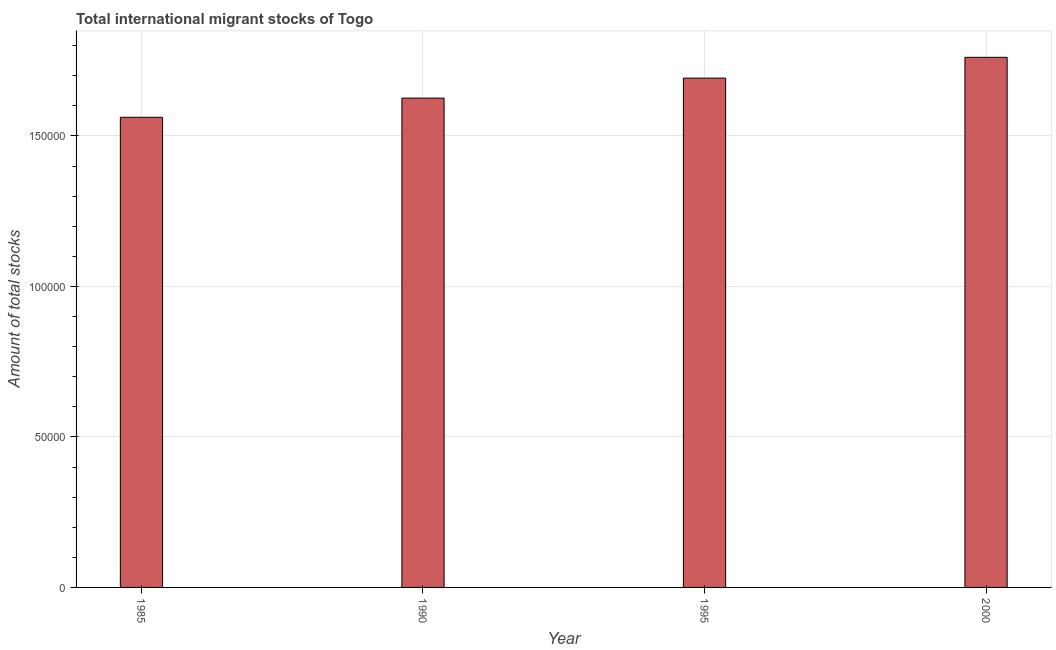What is the title of the graph?
Ensure brevity in your answer.  Total international migrant stocks of Togo. What is the label or title of the X-axis?
Offer a terse response. Year. What is the label or title of the Y-axis?
Your response must be concise. Amount of total stocks. What is the total number of international migrant stock in 1995?
Your answer should be compact. 1.69e+05. Across all years, what is the maximum total number of international migrant stock?
Offer a very short reply. 1.76e+05. Across all years, what is the minimum total number of international migrant stock?
Ensure brevity in your answer.  1.56e+05. In which year was the total number of international migrant stock minimum?
Your answer should be very brief. 1985. What is the sum of the total number of international migrant stock?
Provide a short and direct response. 6.64e+05. What is the difference between the total number of international migrant stock in 1990 and 1995?
Your answer should be compact. -6641. What is the average total number of international migrant stock per year?
Keep it short and to the point. 1.66e+05. What is the median total number of international migrant stock?
Offer a terse response. 1.66e+05. In how many years, is the total number of international migrant stock greater than 140000 ?
Keep it short and to the point. 4. What is the ratio of the total number of international migrant stock in 1995 to that in 2000?
Provide a succinct answer. 0.96. Is the total number of international migrant stock in 1985 less than that in 1990?
Your answer should be compact. Yes. What is the difference between the highest and the second highest total number of international migrant stock?
Your response must be concise. 6906. Is the sum of the total number of international migrant stock in 1990 and 2000 greater than the maximum total number of international migrant stock across all years?
Offer a terse response. Yes. What is the difference between the highest and the lowest total number of international migrant stock?
Give a very brief answer. 1.99e+04. How many bars are there?
Your response must be concise. 4. Are all the bars in the graph horizontal?
Offer a terse response. No. How many years are there in the graph?
Provide a short and direct response. 4. What is the difference between two consecutive major ticks on the Y-axis?
Offer a terse response. 5.00e+04. Are the values on the major ticks of Y-axis written in scientific E-notation?
Offer a terse response. No. What is the Amount of total stocks of 1985?
Keep it short and to the point. 1.56e+05. What is the Amount of total stocks of 1990?
Your response must be concise. 1.63e+05. What is the Amount of total stocks in 1995?
Provide a short and direct response. 1.69e+05. What is the Amount of total stocks in 2000?
Keep it short and to the point. 1.76e+05. What is the difference between the Amount of total stocks in 1985 and 1990?
Give a very brief answer. -6368. What is the difference between the Amount of total stocks in 1985 and 1995?
Your response must be concise. -1.30e+04. What is the difference between the Amount of total stocks in 1985 and 2000?
Offer a terse response. -1.99e+04. What is the difference between the Amount of total stocks in 1990 and 1995?
Your response must be concise. -6641. What is the difference between the Amount of total stocks in 1990 and 2000?
Your answer should be very brief. -1.35e+04. What is the difference between the Amount of total stocks in 1995 and 2000?
Ensure brevity in your answer.  -6906. What is the ratio of the Amount of total stocks in 1985 to that in 1990?
Offer a very short reply. 0.96. What is the ratio of the Amount of total stocks in 1985 to that in 1995?
Make the answer very short. 0.92. What is the ratio of the Amount of total stocks in 1985 to that in 2000?
Offer a terse response. 0.89. What is the ratio of the Amount of total stocks in 1990 to that in 1995?
Provide a short and direct response. 0.96. What is the ratio of the Amount of total stocks in 1990 to that in 2000?
Provide a succinct answer. 0.92. What is the ratio of the Amount of total stocks in 1995 to that in 2000?
Give a very brief answer. 0.96. 